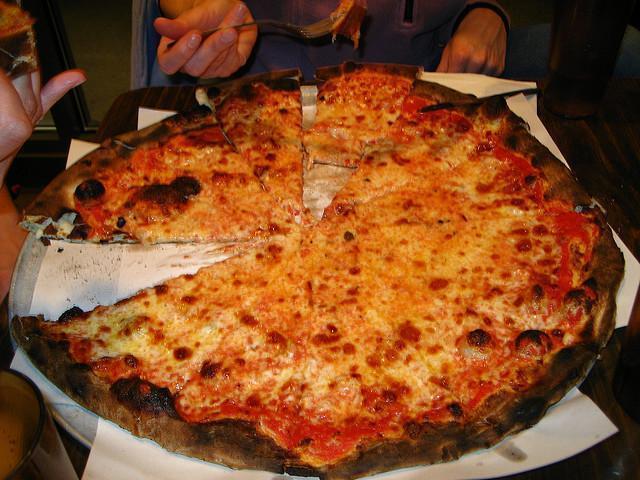How many pieces of pizza are missing?
Give a very brief answer. 1. How many people are in the picture?
Give a very brief answer. 2. How many pizzas are there?
Give a very brief answer. 3. 